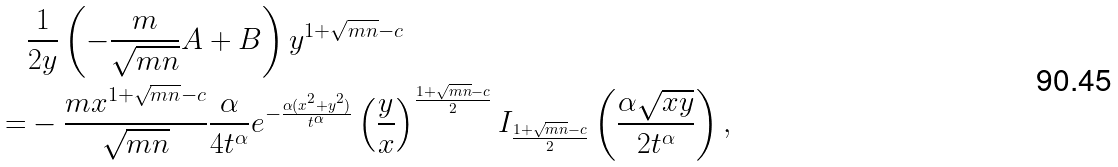Convert formula to latex. <formula><loc_0><loc_0><loc_500><loc_500>& \frac { 1 } { 2 y } \left ( - \frac { m } { \sqrt { m n } } A + B \right ) y ^ { 1 + \sqrt { m n } - c } \\ = & - \frac { m x ^ { 1 + \sqrt { m n } - c } } { \sqrt { m n } } \frac { \alpha } { 4 t ^ { \alpha } } e ^ { - \frac { \alpha ( x ^ { 2 } + y ^ { 2 } ) } { t ^ { \alpha } } } \left ( \frac { y } { x } \right ) ^ { \frac { 1 + \sqrt { m n } - c } { 2 } } I _ { \frac { 1 + \sqrt { m n } - c } { 2 } } \left ( \frac { \alpha \sqrt { x y } } { 2 t ^ { \alpha } } \right ) ,</formula> 